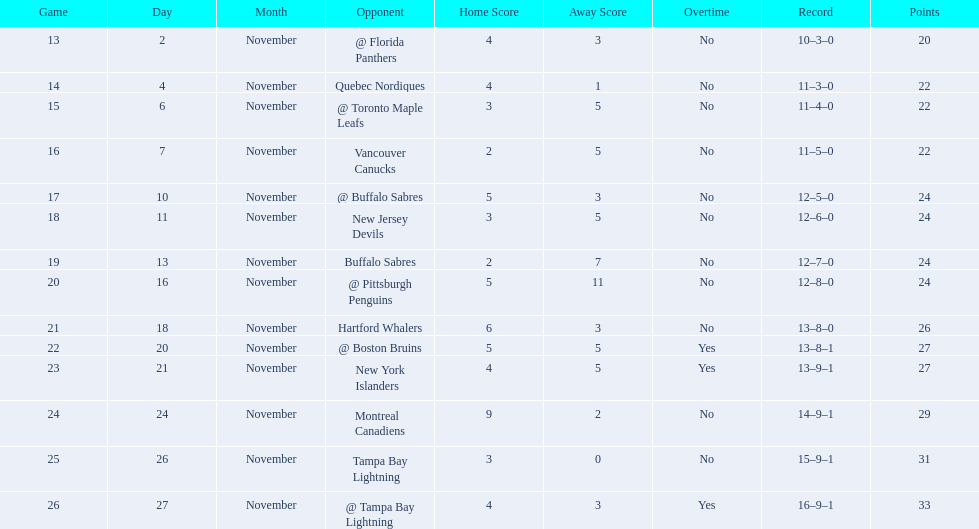What were the scores? @ Florida Panthers, 4–3, Quebec Nordiques, 4–1, @ Toronto Maple Leafs, 3–5, Vancouver Canucks, 2–5, @ Buffalo Sabres, 5–3, New Jersey Devils, 3–5, Buffalo Sabres, 2–7, @ Pittsburgh Penguins, 5–11, Hartford Whalers, 6–3, @ Boston Bruins, 5–5 OT, New York Islanders, 4–5 OT, Montreal Canadiens, 9–2, Tampa Bay Lightning, 3–0, @ Tampa Bay Lightning, 4–3 OT. What score was the closest? New York Islanders, 4–5 OT. What team had that score? New York Islanders. 